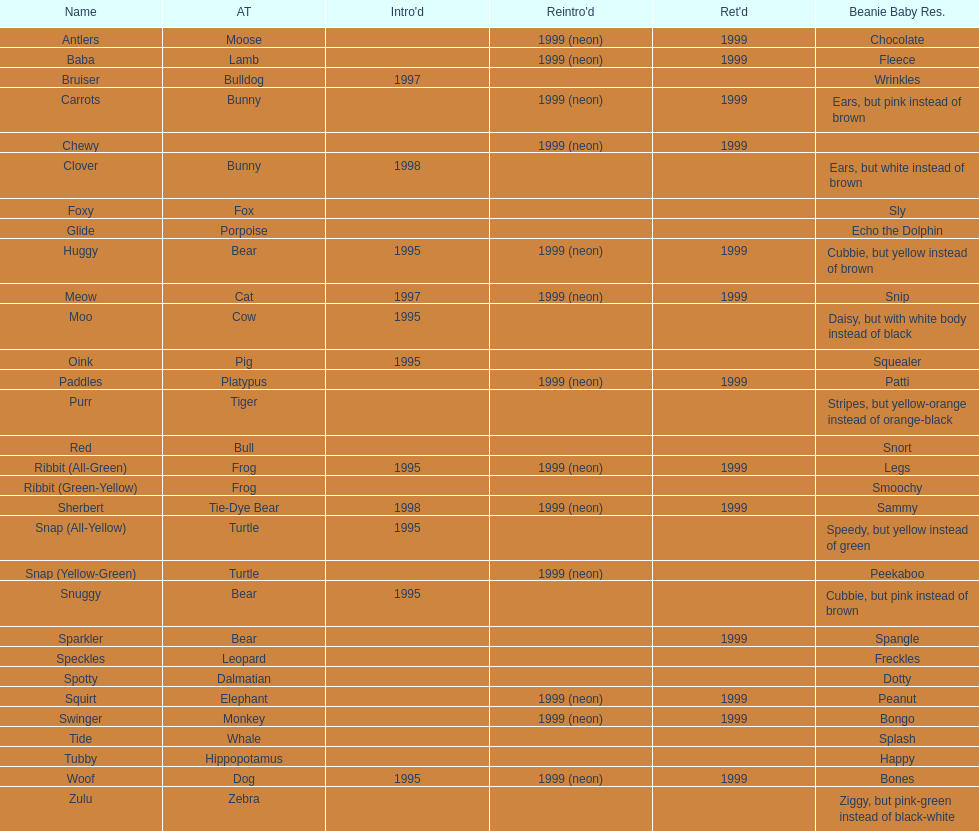Tell me the number of pillow pals reintroduced in 1999. 13. 